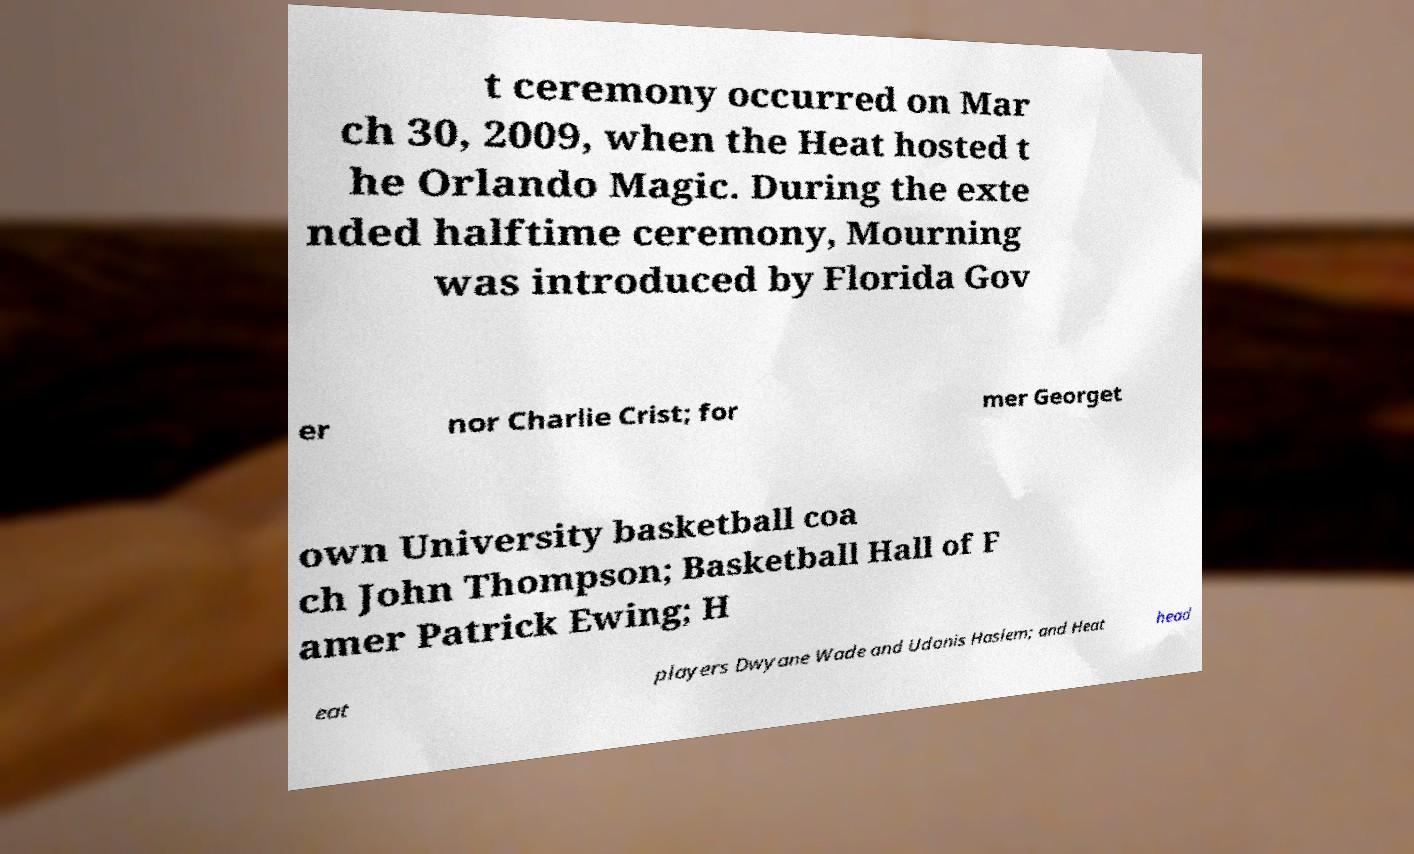Could you extract and type out the text from this image? t ceremony occurred on Mar ch 30, 2009, when the Heat hosted t he Orlando Magic. During the exte nded halftime ceremony, Mourning was introduced by Florida Gov er nor Charlie Crist; for mer Georget own University basketball coa ch John Thompson; Basketball Hall of F amer Patrick Ewing; H eat players Dwyane Wade and Udonis Haslem; and Heat head 